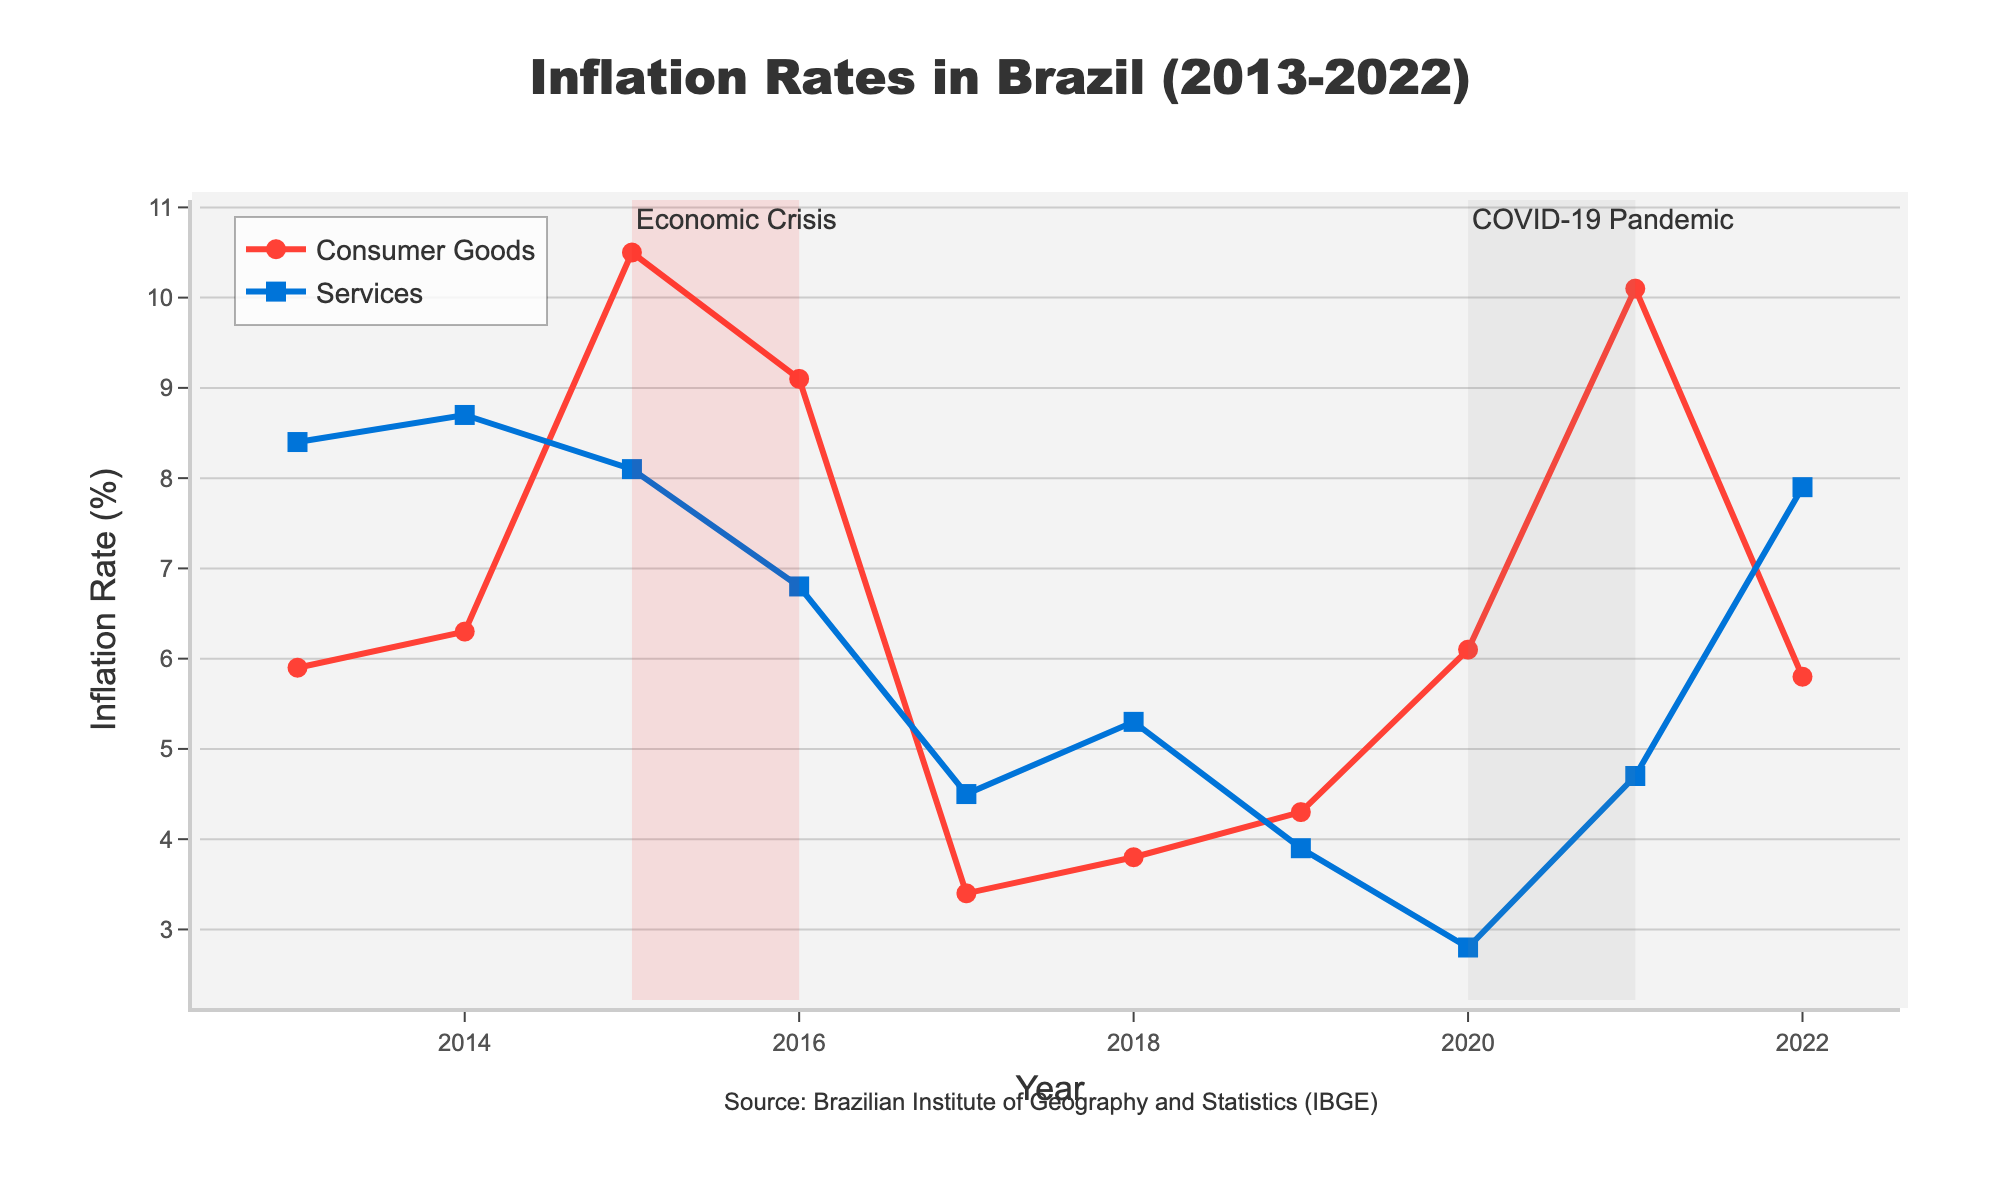What's the title of the figure? The title is shown at the top center of the figure. It clearly reads 'Inflation Rates in Brazil (2013-2022)'.
Answer: Inflation Rates in Brazil (2013-2022) What is the average inflation rate for consumer goods over the years? Add the inflation rates of consumer goods for all the years and divide by the number of years. (5.9 + 6.3 + 10.5 + 9.1 + 3.4 + 3.8 + 4.3 + 6.1 + 10.1 + 5.8) / 10 = 65.3 / 10 = 6.53
Answer: 6.53% Which year had the highest inflation rate for consumer goods? Look at the highest point for the consumer goods line (red color with circle markers). The year label for this point is 2015.
Answer: 2015 In which year did the services inflation rate reach its lowest point? Find the lowest point on the services inflation line (blue color with square markers). The year for this point, which is the lowest, is 2020.
Answer: 2020 Compare the inflation rates of consumer goods and services in 2016. Which one was higher? Look at the data points for both consumer goods and services in 2016. The consumer goods inflation rate was 9.1% and the services inflation rate was 6.8%. 9.1 is greater than 6.8.
Answer: Consumer goods What were the effects of the economic crisis marked on the graph? Check the shaded red area labeled 'Economic Crisis' covering 2015 to 2016. During this period, the consumer goods inflation rate peaked in 2015, and it significantly decreased in 2016. Services inflation also decreased.
Answer: Both consumer goods and services inflation decreased in 2016 What is the main visual difference between the consumer goods and services inflation lines? Observe the styles of the two lines. The consumer goods line is red with circle markers, while the services line is blue with square markers.
Answer: Consumer goods: red with circles; Services: blue with squares Between which years did the consumer goods inflation rate decrease the most sharply? Examine the red line for the steepest decline. The largest drop is from 2015 to 2017, decreasing from 10.5% to 3.4%.
Answer: 2015 to 2017 What is the general trend of services inflation rate over the years displayed? Look at the blue line. It generally shows a decreasing trend from 2013 (8.4%) to 2020 (2.8%) but then rises again to 7.9% in 2022.
Answer: Decreasing then increasing How did the COVID-19 Pandemic affect the inflation rates for consumer goods and services? Look at the shaded grey area labeled 'COVID-19 Pandemic' covering 2020 to 2021. Consumer goods inflation increased from 6.1% to 10.1%, while services inflation increased from 2.8% to 4.7%.
Answer: Both increased 